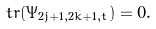Convert formula to latex. <formula><loc_0><loc_0><loc_500><loc_500>\ t r ( \Psi _ { 2 j + 1 , 2 k + 1 , t } ) = 0 .</formula> 